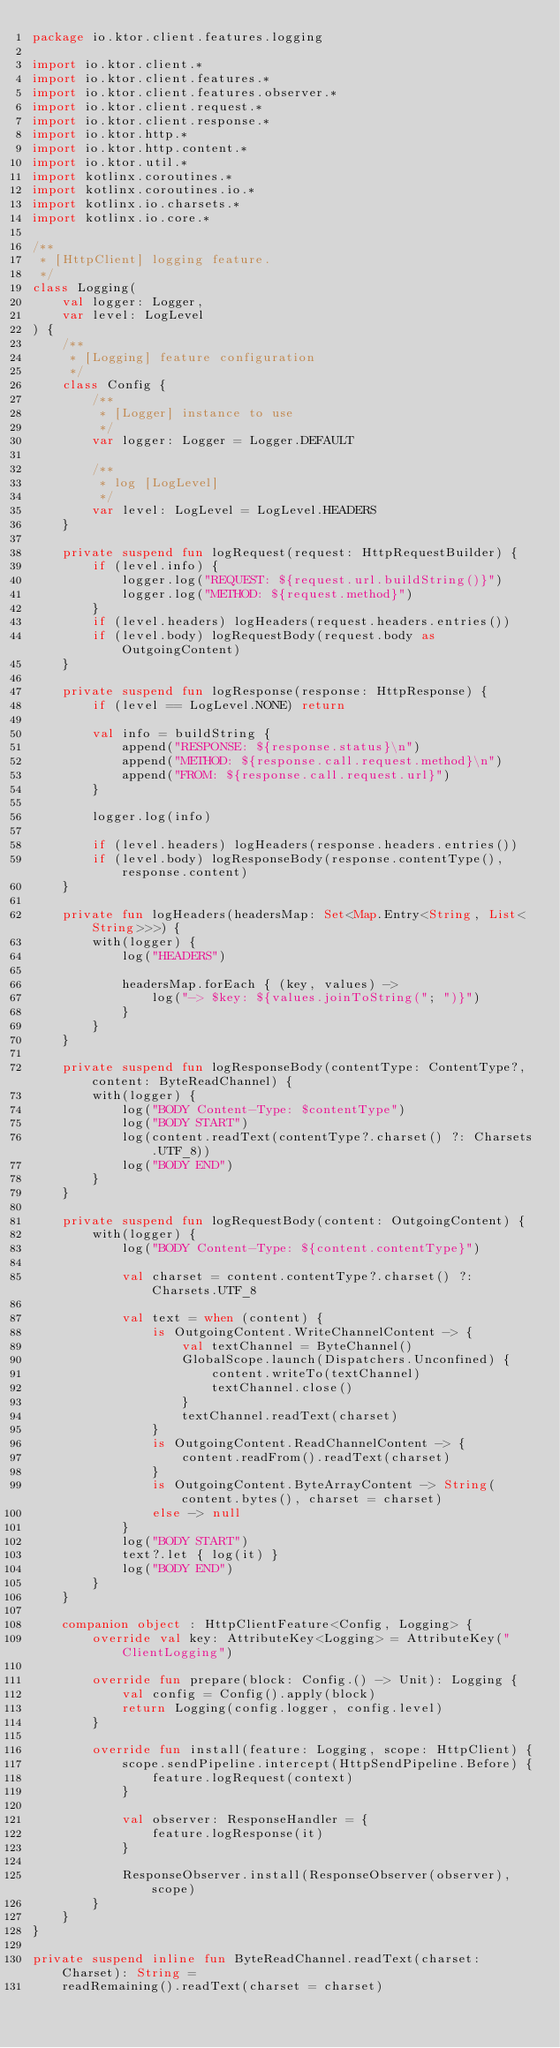<code> <loc_0><loc_0><loc_500><loc_500><_Kotlin_>package io.ktor.client.features.logging

import io.ktor.client.*
import io.ktor.client.features.*
import io.ktor.client.features.observer.*
import io.ktor.client.request.*
import io.ktor.client.response.*
import io.ktor.http.*
import io.ktor.http.content.*
import io.ktor.util.*
import kotlinx.coroutines.*
import kotlinx.coroutines.io.*
import kotlinx.io.charsets.*
import kotlinx.io.core.*

/**
 * [HttpClient] logging feature.
 */
class Logging(
    val logger: Logger,
    var level: LogLevel
) {
    /**
     * [Logging] feature configuration
     */
    class Config {
        /**
         * [Logger] instance to use
         */
        var logger: Logger = Logger.DEFAULT

        /**
         * log [LogLevel]
         */
        var level: LogLevel = LogLevel.HEADERS
    }

    private suspend fun logRequest(request: HttpRequestBuilder) {
        if (level.info) {
            logger.log("REQUEST: ${request.url.buildString()}")
            logger.log("METHOD: ${request.method}")
        }
        if (level.headers) logHeaders(request.headers.entries())
        if (level.body) logRequestBody(request.body as OutgoingContent)
    }

    private suspend fun logResponse(response: HttpResponse) {
        if (level == LogLevel.NONE) return

        val info = buildString {
            append("RESPONSE: ${response.status}\n")
            append("METHOD: ${response.call.request.method}\n")
            append("FROM: ${response.call.request.url}")
        }

        logger.log(info)

        if (level.headers) logHeaders(response.headers.entries())
        if (level.body) logResponseBody(response.contentType(), response.content)
    }

    private fun logHeaders(headersMap: Set<Map.Entry<String, List<String>>>) {
        with(logger) {
            log("HEADERS")

            headersMap.forEach { (key, values) ->
                log("-> $key: ${values.joinToString("; ")}")
            }
        }
    }

    private suspend fun logResponseBody(contentType: ContentType?, content: ByteReadChannel) {
        with(logger) {
            log("BODY Content-Type: $contentType")
            log("BODY START")
            log(content.readText(contentType?.charset() ?: Charsets.UTF_8))
            log("BODY END")
        }
    }

    private suspend fun logRequestBody(content: OutgoingContent) {
        with(logger) {
            log("BODY Content-Type: ${content.contentType}")

            val charset = content.contentType?.charset() ?: Charsets.UTF_8

            val text = when (content) {
                is OutgoingContent.WriteChannelContent -> {
                    val textChannel = ByteChannel()
                    GlobalScope.launch(Dispatchers.Unconfined) {
                        content.writeTo(textChannel)
                        textChannel.close()
                    }
                    textChannel.readText(charset)
                }
                is OutgoingContent.ReadChannelContent -> {
                    content.readFrom().readText(charset)
                }
                is OutgoingContent.ByteArrayContent -> String(content.bytes(), charset = charset)
                else -> null
            }
            log("BODY START")
            text?.let { log(it) }
            log("BODY END")
        }
    }

    companion object : HttpClientFeature<Config, Logging> {
        override val key: AttributeKey<Logging> = AttributeKey("ClientLogging")

        override fun prepare(block: Config.() -> Unit): Logging {
            val config = Config().apply(block)
            return Logging(config.logger, config.level)
        }

        override fun install(feature: Logging, scope: HttpClient) {
            scope.sendPipeline.intercept(HttpSendPipeline.Before) {
                feature.logRequest(context)
            }

            val observer: ResponseHandler = {
                feature.logResponse(it)
            }

            ResponseObserver.install(ResponseObserver(observer), scope)
        }
    }
}

private suspend inline fun ByteReadChannel.readText(charset: Charset): String =
    readRemaining().readText(charset = charset)
</code> 